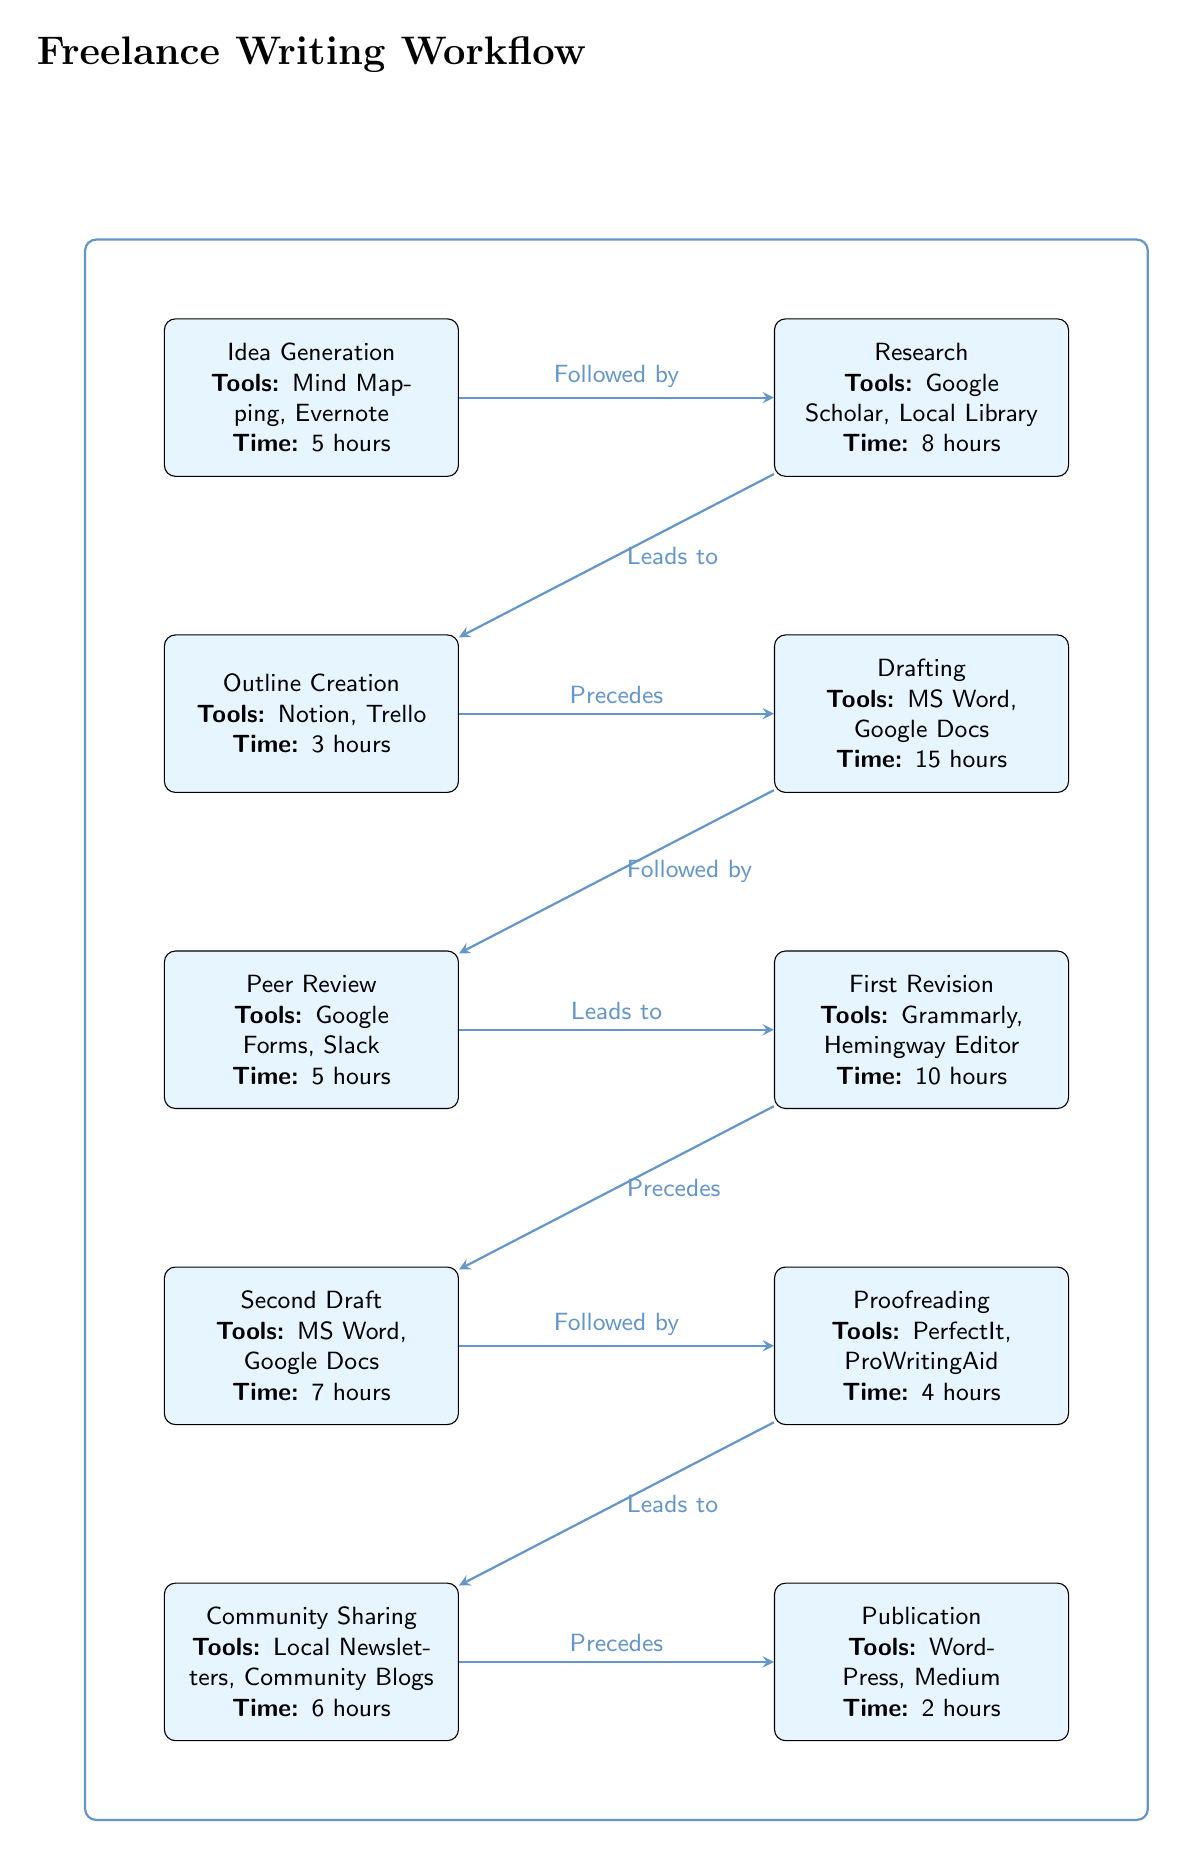What is the first stage of the writing process? The diagram clearly labels the first stage as "Idea Generation," which is positioned at the top left of the workflow.
Answer: Idea Generation How many hours are dedicated to Drafting? The diagram lists the time spent on the Drafting stage as 15 hours, which is directly tied to that specific node.
Answer: 15 hours What tools are used during the Peer Review stage? Looking at the Peer Review node, it lists the tools as "Google Forms, Slack," which can be directly read from the visual.
Answer: Google Forms, Slack What stage comes after the First Revision? The diagram shows an arrow leading from the First Revision node to the Second Draft node, indicating that it follows directly after.
Answer: Second Draft How many total stages are illustrated in the diagram? By counting each process node in the diagram, there are ten distinct stages presented as part of the writing workflow.
Answer: 10 What is the total time spent from Idea Generation to Publication? To find this, you sum the time dedicated to each stage: 5 + 8 + 3 + 15 + 5 + 10 + 7 + 4 + 6 + 2, resulting in a total of 61 hours.
Answer: 61 hours Which stage involves Community Sharing, and what tools are used? Community Sharing is a process node on the bottom right; it lists the tools utilized as "Local Newsletters, Community Blogs."
Answer: Local Newsletters, Community Blogs How does the Research stage relate to Outline Creation? The diagram indicates that the Research stage leads to, or is followed by, the Outline Creation stage, which illustrates the sequential flow of the writing process.
Answer: Leads to 